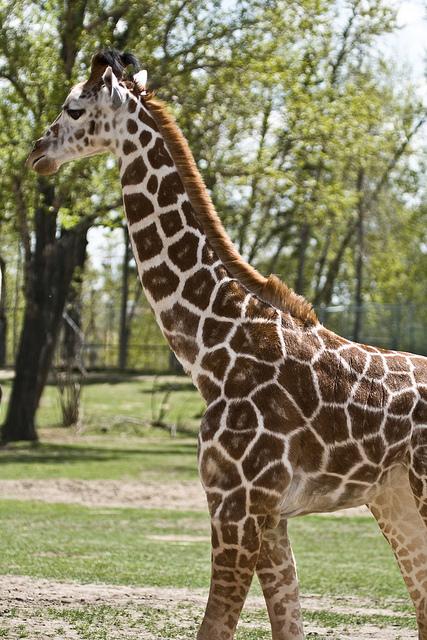What is this animal?
Keep it brief. Giraffe. Are all the spots on the animal exactly alike?
Give a very brief answer. No. Which is longer, the neck or the front legs?
Answer briefly. Neck. 